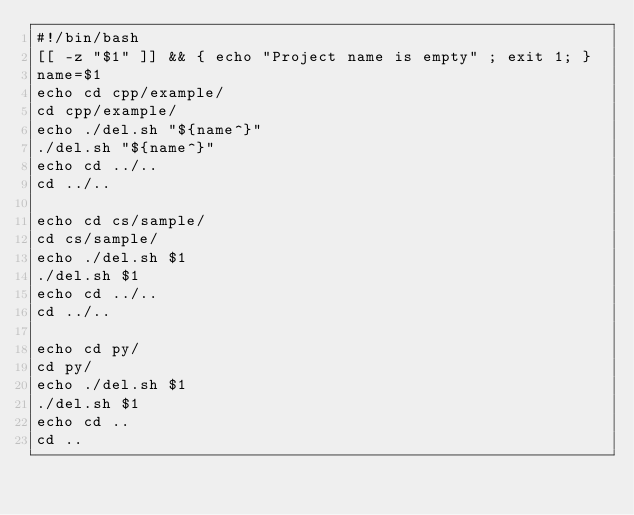Convert code to text. <code><loc_0><loc_0><loc_500><loc_500><_Bash_>#!/bin/bash
[[ -z "$1" ]] && { echo "Project name is empty" ; exit 1; }
name=$1
echo cd cpp/example/
cd cpp/example/
echo ./del.sh "${name^}"
./del.sh "${name^}"
echo cd ../..
cd ../..

echo cd cs/sample/
cd cs/sample/
echo ./del.sh $1
./del.sh $1
echo cd ../..
cd ../..

echo cd py/
cd py/
echo ./del.sh $1
./del.sh $1
echo cd ..
cd ..
</code> 